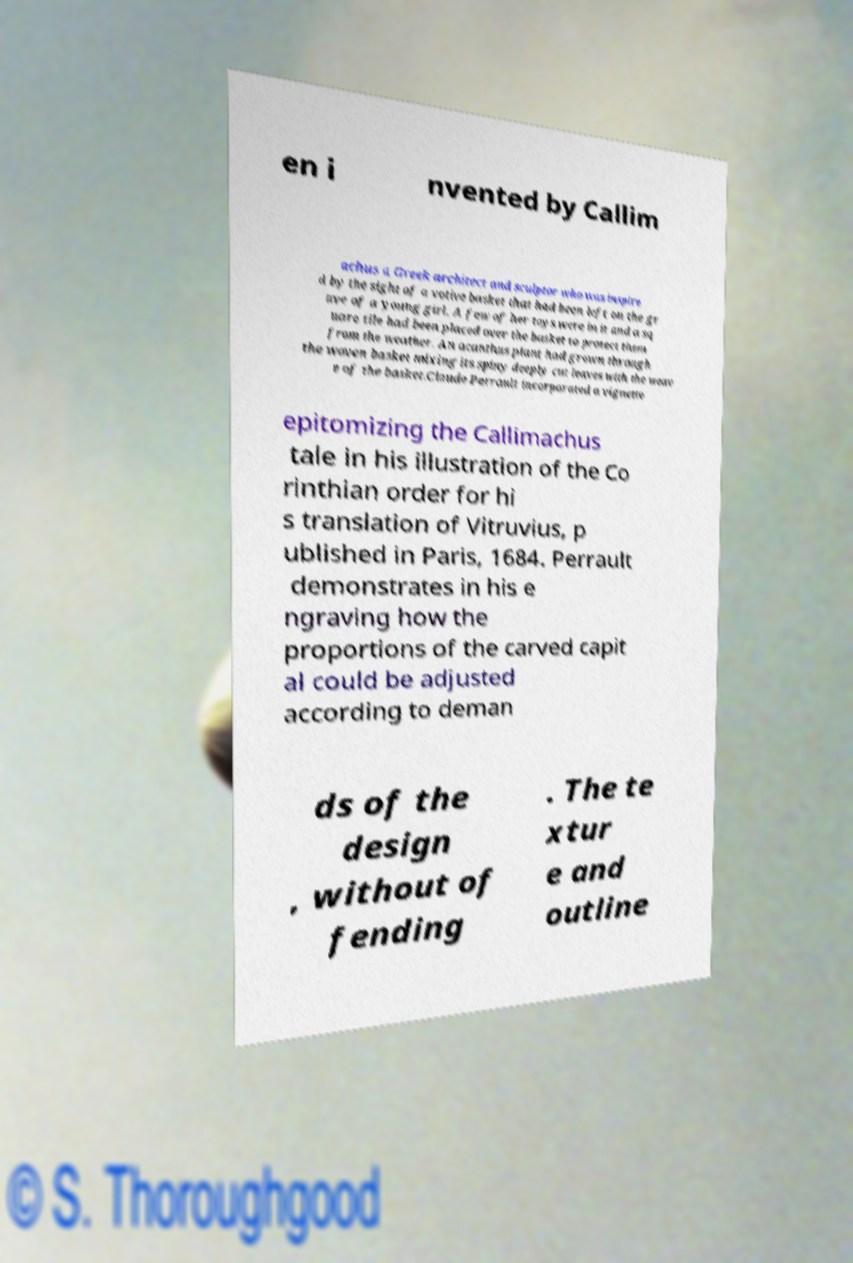Could you extract and type out the text from this image? en i nvented by Callim achus a Greek architect and sculptor who was inspire d by the sight of a votive basket that had been left on the gr ave of a young girl. A few of her toys were in it and a sq uare tile had been placed over the basket to protect them from the weather. An acanthus plant had grown through the woven basket mixing its spiny deeply cut leaves with the weav e of the basket.Claude Perrault incorporated a vignette epitomizing the Callimachus tale in his illustration of the Co rinthian order for hi s translation of Vitruvius, p ublished in Paris, 1684. Perrault demonstrates in his e ngraving how the proportions of the carved capit al could be adjusted according to deman ds of the design , without of fending . The te xtur e and outline 